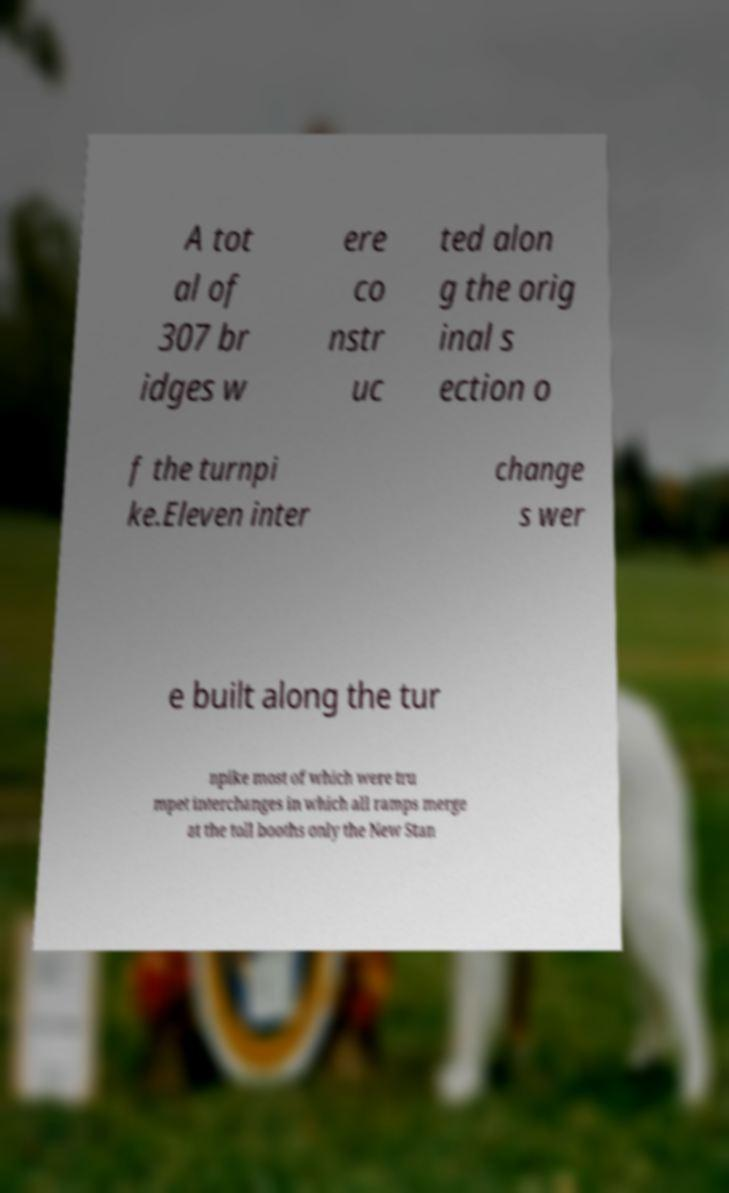Could you extract and type out the text from this image? A tot al of 307 br idges w ere co nstr uc ted alon g the orig inal s ection o f the turnpi ke.Eleven inter change s wer e built along the tur npike most of which were tru mpet interchanges in which all ramps merge at the toll booths only the New Stan 